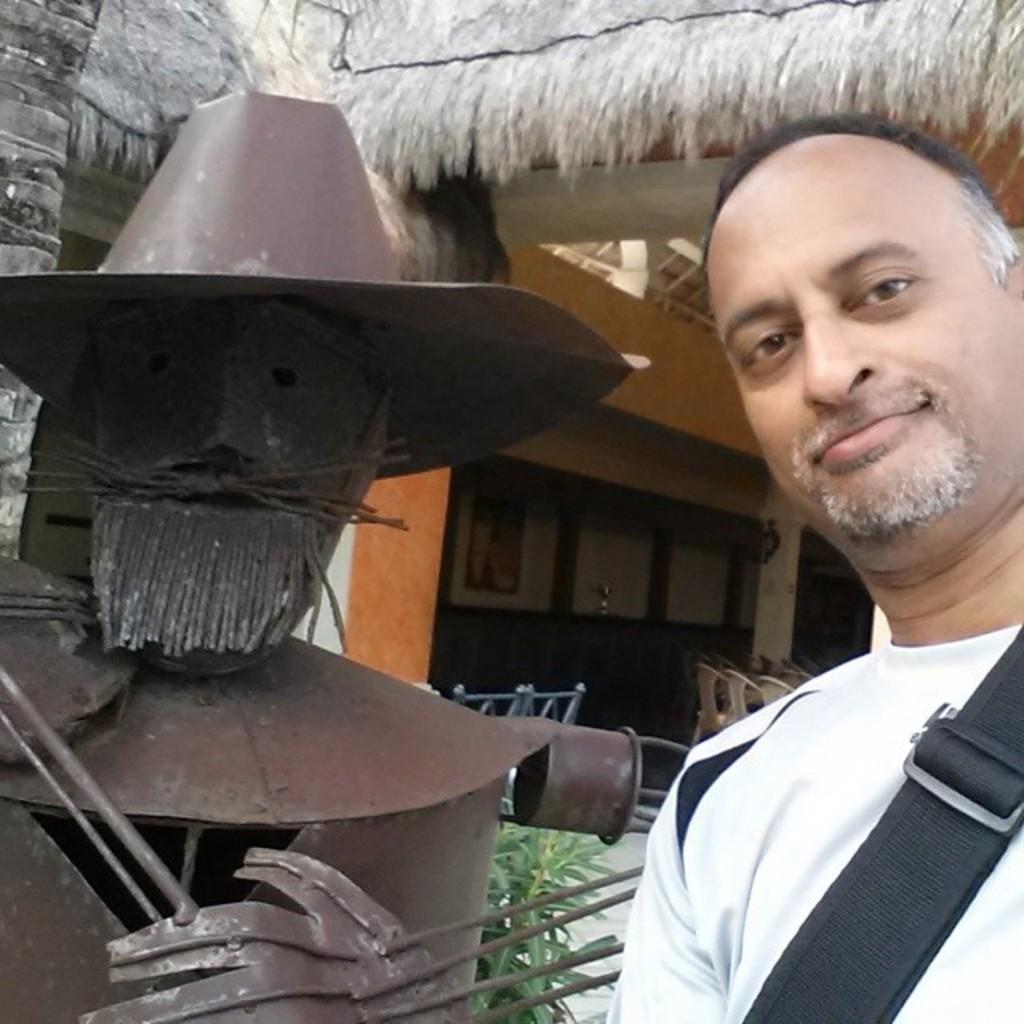What is the main subject of the image? There is a person in the image. What can be seen in the background of the image? There is a house and plants in the background of the image. What type of instrument is the person playing in the image? There is no instrument present in the image; it only features a person and a background with a house and plants. How many eyes does the person have in the image? The number of eyes cannot be determined from the image, as it only shows a person and a background with a house and plants. 